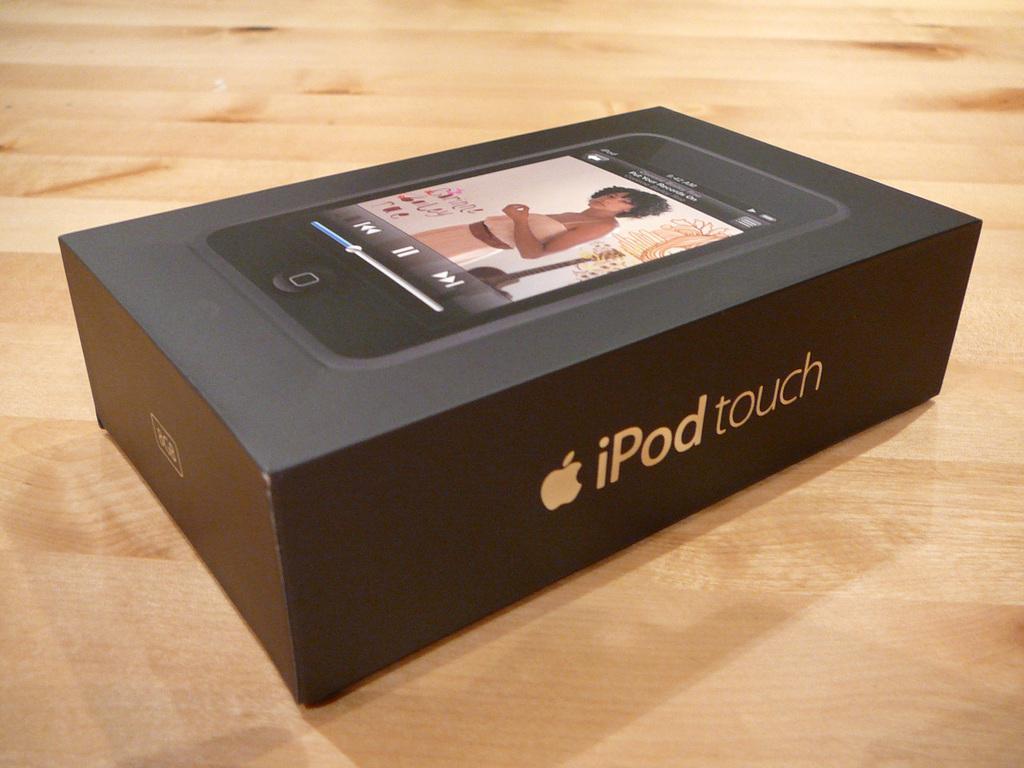Please provide a concise description of this image. In this image there is a table, on that table there is a box. 